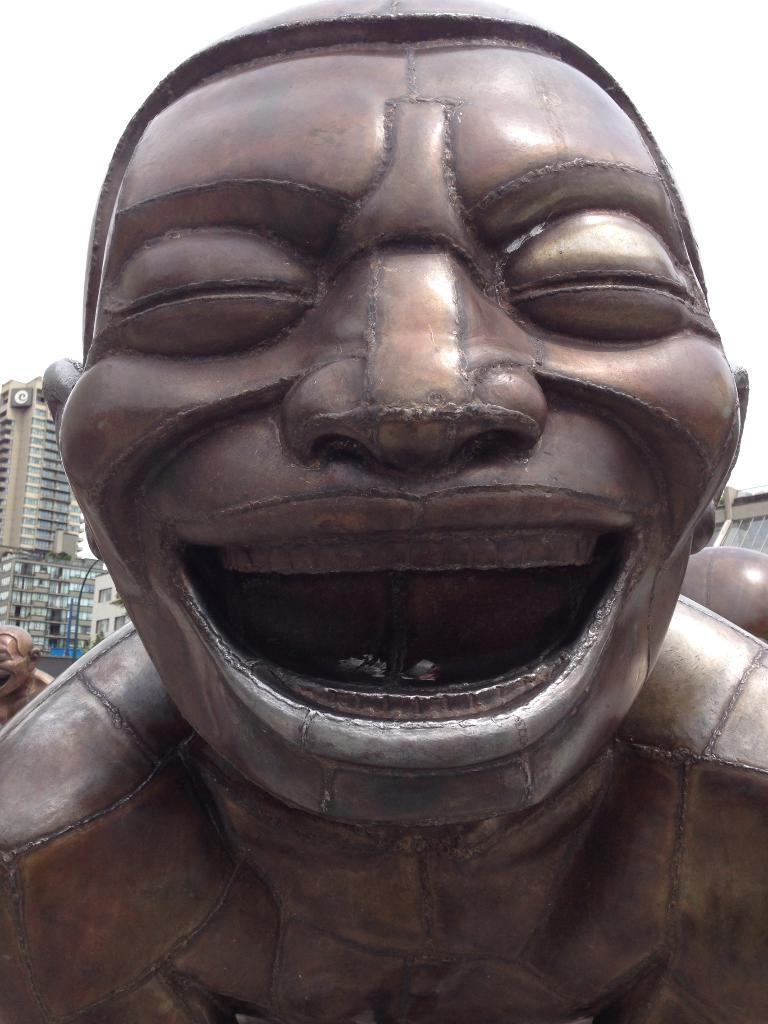What is the main subject of the image? There is a statue of a person in the image. What can be seen in the background of the image? There are buildings in the background of the image. What is visible at the top of the image? The sky is visible at the top of the image. What language is the statue speaking in the image? The statue is not speaking, and therefore, there is no language present in the image. 